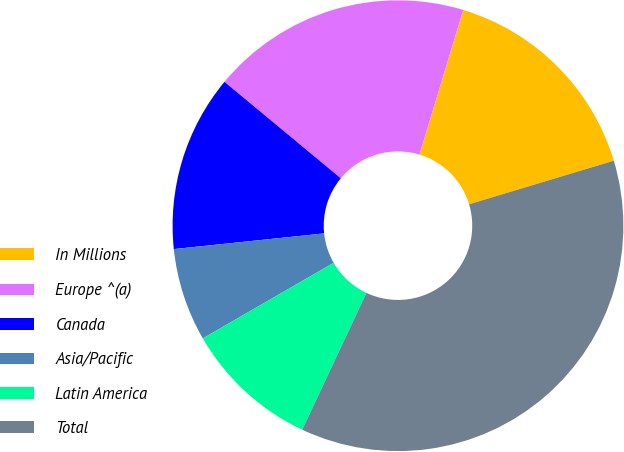Convert chart. <chart><loc_0><loc_0><loc_500><loc_500><pie_chart><fcel>In Millions<fcel>Europe ^(a)<fcel>Canada<fcel>Asia/Pacific<fcel>Latin America<fcel>Total<nl><fcel>15.67%<fcel>18.66%<fcel>12.67%<fcel>6.68%<fcel>9.68%<fcel>36.64%<nl></chart> 